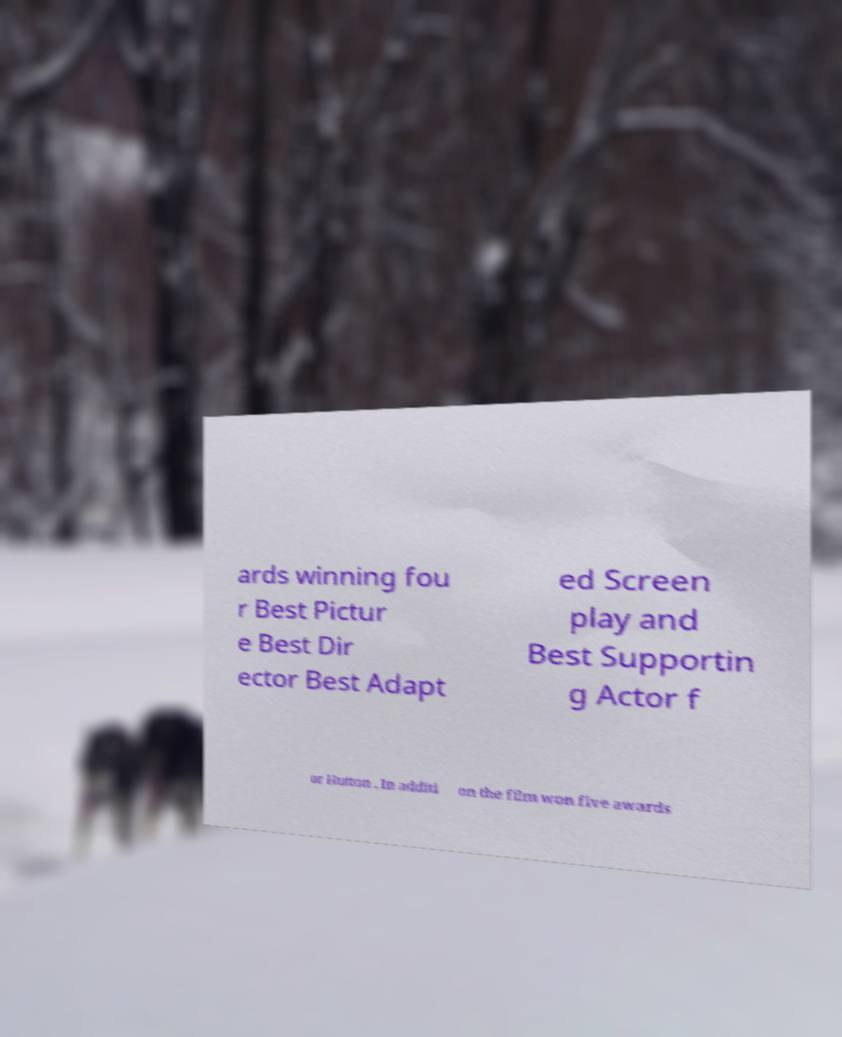There's text embedded in this image that I need extracted. Can you transcribe it verbatim? ards winning fou r Best Pictur e Best Dir ector Best Adapt ed Screen play and Best Supportin g Actor f or Hutton . In additi on the film won five awards 